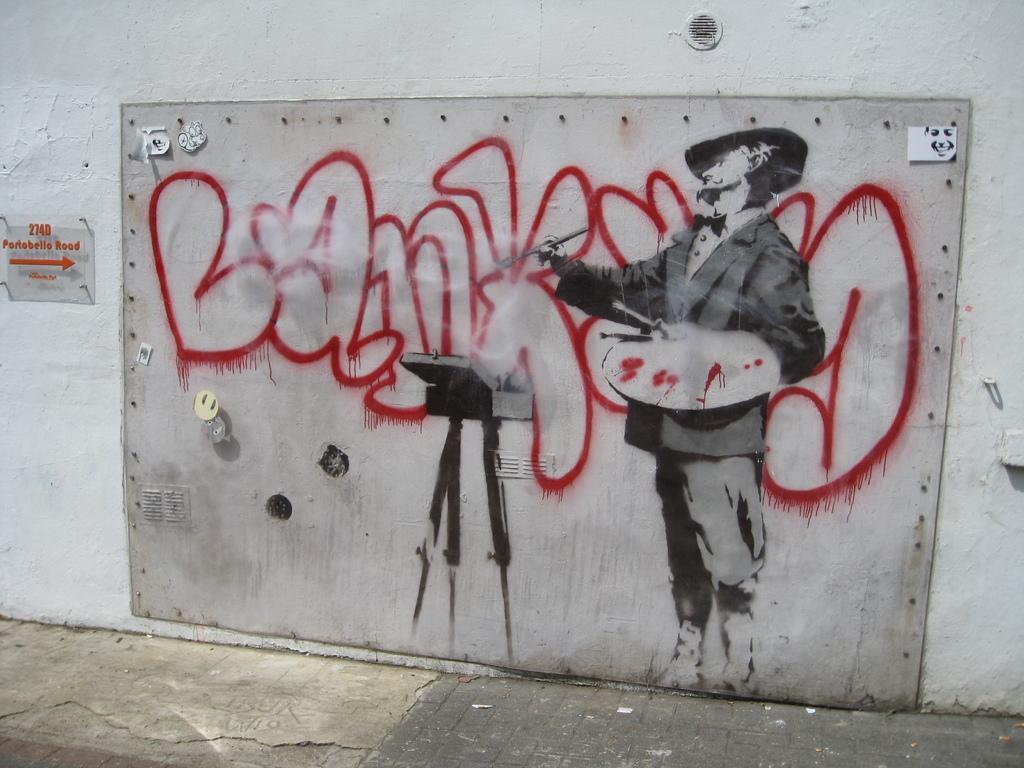Can you describe this image briefly? In this picture I can see a painting on the wall and a glass board with some text. 